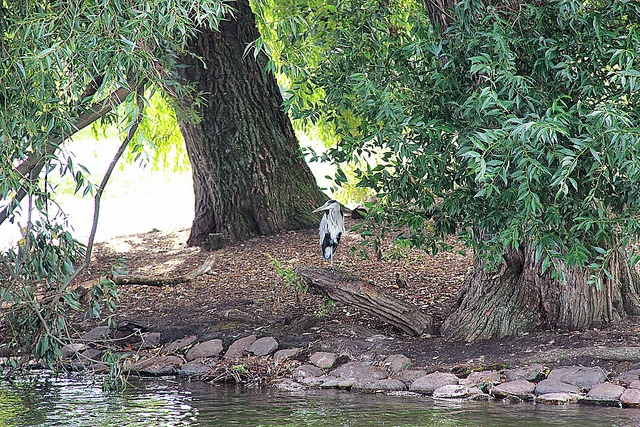Describe the objects in this image and their specific colors. I can see a bird in darkgreen, lightgray, darkgray, black, and gray tones in this image. 